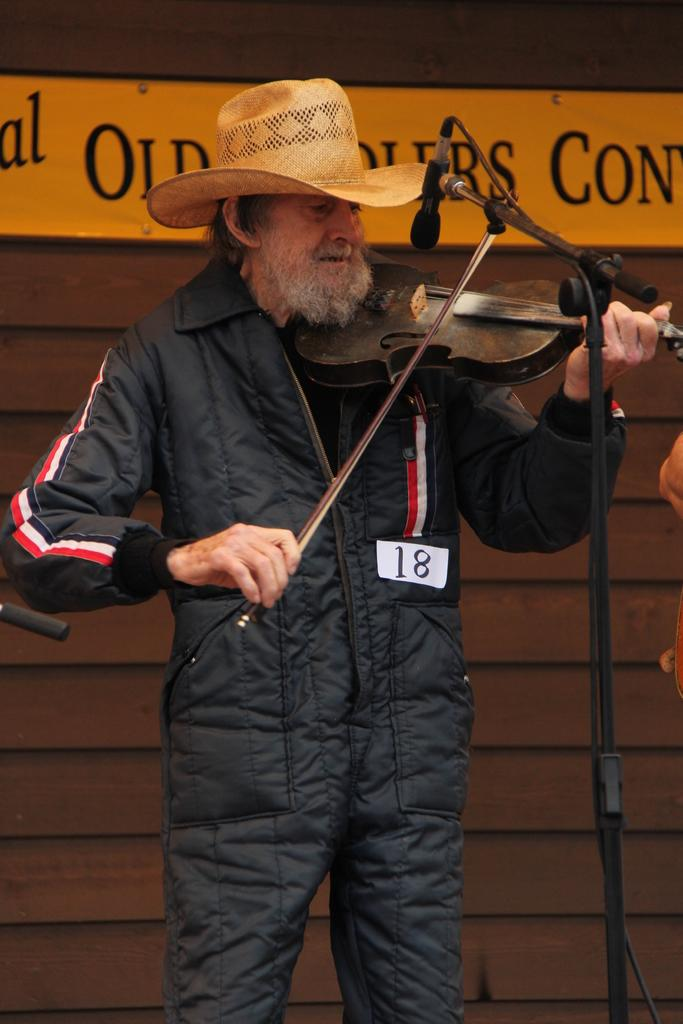What is the person in the image doing? The person is playing a musical instrument. What is the person wearing on their head? The person is wearing a cap. What equipment is present for amplifying sound in the image? There is a microphone with a stand in the image. What can be seen in the background of the image? There is a wall visible in the background of the image. Can you see the person's friend holding a pencil in the image? There is no friend or pencil present in the image. 